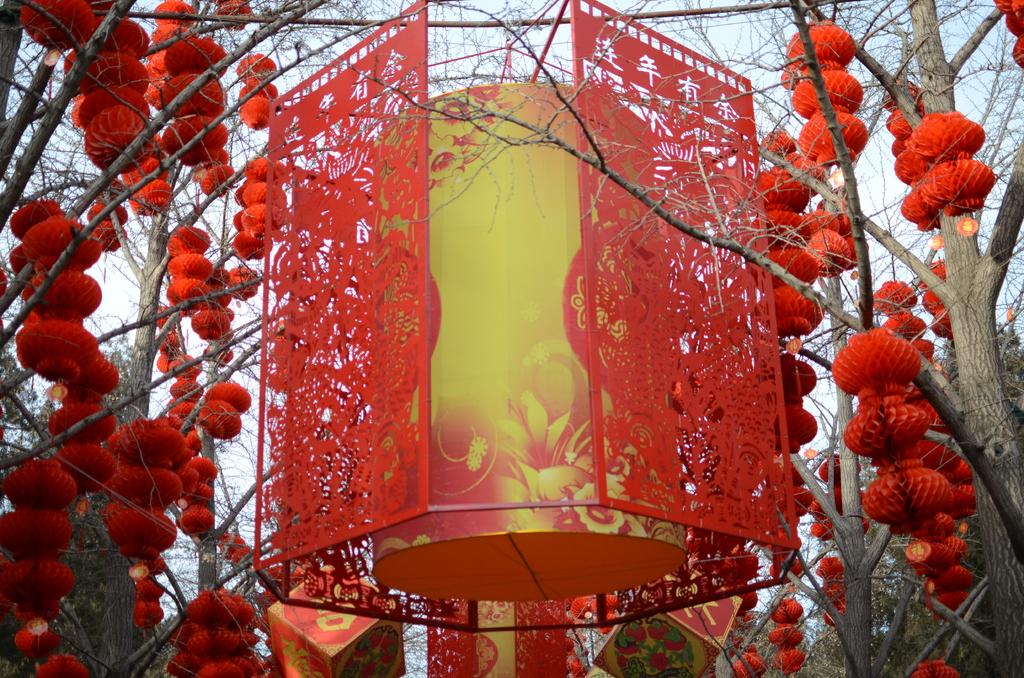What type of decorations can be seen in the image? There are Chinese lanterns in the image. How are the Chinese lanterns positioned in the image? The Chinese lanterns are hanging from trees. What can be seen in the background of the image? There is sky visible in the background of the image. What type of sugar is being used to sweeten the bean in the image? There is no sugar or bean present in the image; it features Chinese lanterns hanging from trees. 